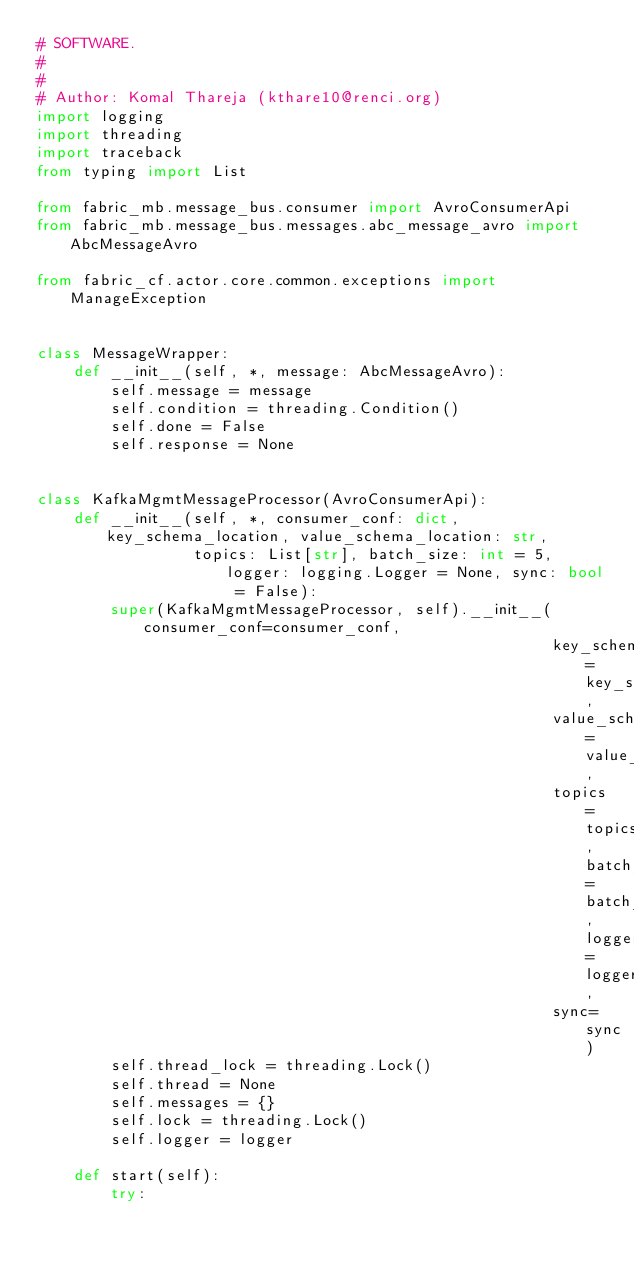Convert code to text. <code><loc_0><loc_0><loc_500><loc_500><_Python_># SOFTWARE.
#
#
# Author: Komal Thareja (kthare10@renci.org)
import logging
import threading
import traceback
from typing import List

from fabric_mb.message_bus.consumer import AvroConsumerApi
from fabric_mb.message_bus.messages.abc_message_avro import AbcMessageAvro

from fabric_cf.actor.core.common.exceptions import ManageException


class MessageWrapper:
    def __init__(self, *, message: AbcMessageAvro):
        self.message = message
        self.condition = threading.Condition()
        self.done = False
        self.response = None


class KafkaMgmtMessageProcessor(AvroConsumerApi):
    def __init__(self, *, consumer_conf: dict, key_schema_location, value_schema_location: str,
                 topics: List[str], batch_size: int = 5, logger: logging.Logger = None, sync: bool = False):
        super(KafkaMgmtMessageProcessor, self).__init__(consumer_conf=consumer_conf,
                                                        key_schema_location=key_schema_location,
                                                        value_schema_location=value_schema_location,
                                                        topics=topics, batch_size=batch_size, logger=logger,
                                                        sync=sync)
        self.thread_lock = threading.Lock()
        self.thread = None
        self.messages = {}
        self.lock = threading.Lock()
        self.logger = logger

    def start(self):
        try:</code> 